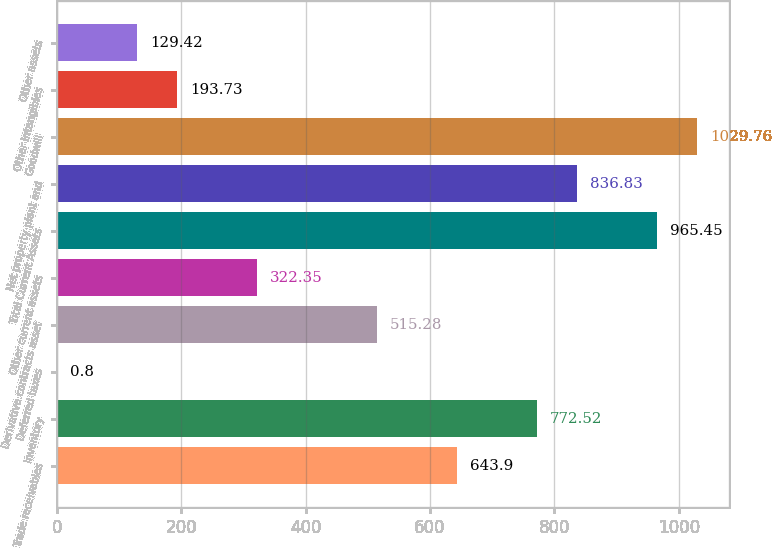<chart> <loc_0><loc_0><loc_500><loc_500><bar_chart><fcel>Trade receivables<fcel>Inventory<fcel>Deferred taxes<fcel>Derivative contracts asset<fcel>Other current assets<fcel>Total Current Assets<fcel>Net property plant and<fcel>Goodwill<fcel>Other intangibles<fcel>Other assets<nl><fcel>643.9<fcel>772.52<fcel>0.8<fcel>515.28<fcel>322.35<fcel>965.45<fcel>836.83<fcel>1029.76<fcel>193.73<fcel>129.42<nl></chart> 